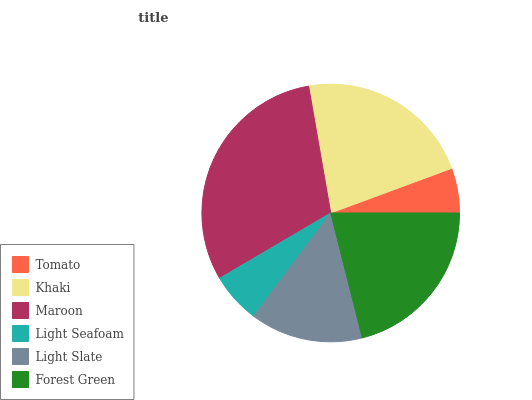Is Tomato the minimum?
Answer yes or no. Yes. Is Maroon the maximum?
Answer yes or no. Yes. Is Khaki the minimum?
Answer yes or no. No. Is Khaki the maximum?
Answer yes or no. No. Is Khaki greater than Tomato?
Answer yes or no. Yes. Is Tomato less than Khaki?
Answer yes or no. Yes. Is Tomato greater than Khaki?
Answer yes or no. No. Is Khaki less than Tomato?
Answer yes or no. No. Is Forest Green the high median?
Answer yes or no. Yes. Is Light Slate the low median?
Answer yes or no. Yes. Is Light Slate the high median?
Answer yes or no. No. Is Khaki the low median?
Answer yes or no. No. 